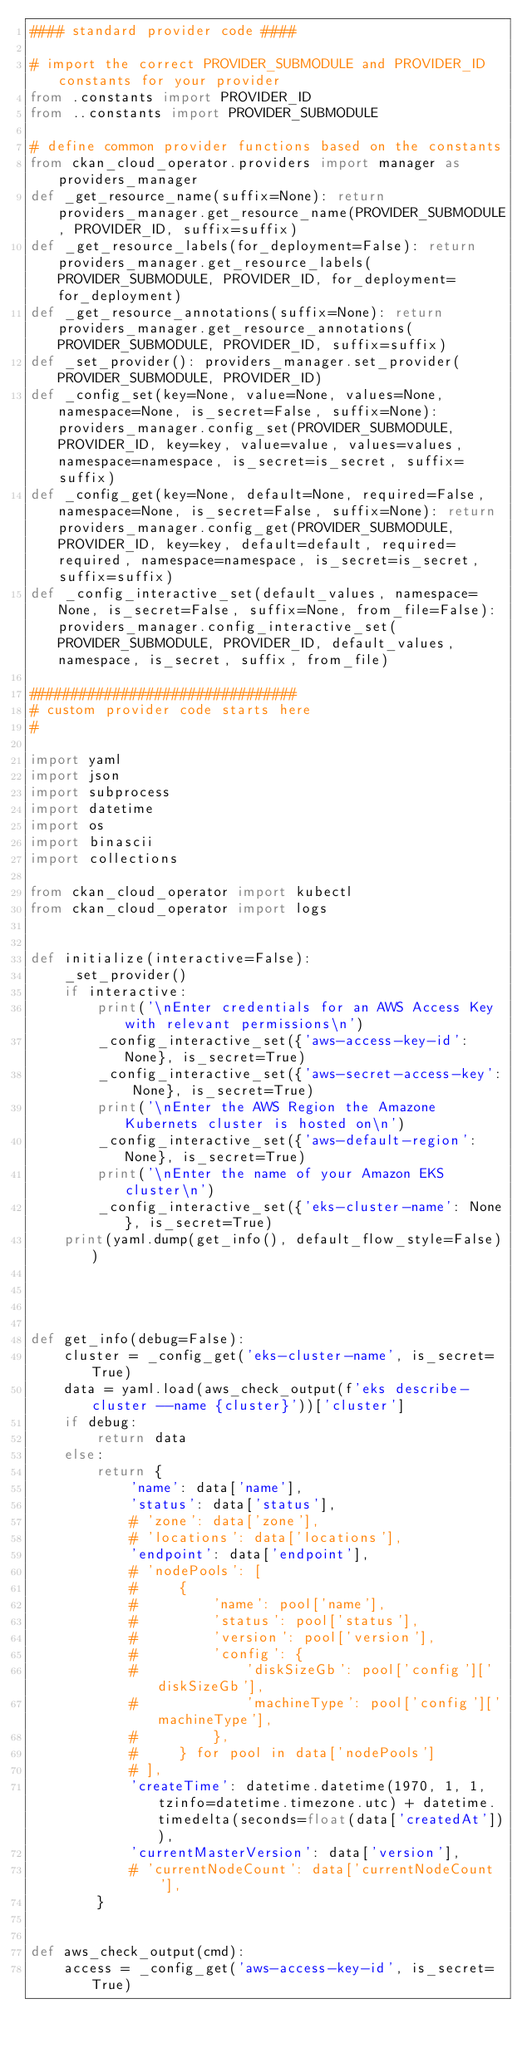Convert code to text. <code><loc_0><loc_0><loc_500><loc_500><_Python_>#### standard provider code ####

# import the correct PROVIDER_SUBMODULE and PROVIDER_ID constants for your provider
from .constants import PROVIDER_ID
from ..constants import PROVIDER_SUBMODULE

# define common provider functions based on the constants
from ckan_cloud_operator.providers import manager as providers_manager
def _get_resource_name(suffix=None): return providers_manager.get_resource_name(PROVIDER_SUBMODULE, PROVIDER_ID, suffix=suffix)
def _get_resource_labels(for_deployment=False): return providers_manager.get_resource_labels(PROVIDER_SUBMODULE, PROVIDER_ID, for_deployment=for_deployment)
def _get_resource_annotations(suffix=None): return providers_manager.get_resource_annotations(PROVIDER_SUBMODULE, PROVIDER_ID, suffix=suffix)
def _set_provider(): providers_manager.set_provider(PROVIDER_SUBMODULE, PROVIDER_ID)
def _config_set(key=None, value=None, values=None, namespace=None, is_secret=False, suffix=None): providers_manager.config_set(PROVIDER_SUBMODULE, PROVIDER_ID, key=key, value=value, values=values, namespace=namespace, is_secret=is_secret, suffix=suffix)
def _config_get(key=None, default=None, required=False, namespace=None, is_secret=False, suffix=None): return providers_manager.config_get(PROVIDER_SUBMODULE, PROVIDER_ID, key=key, default=default, required=required, namespace=namespace, is_secret=is_secret, suffix=suffix)
def _config_interactive_set(default_values, namespace=None, is_secret=False, suffix=None, from_file=False): providers_manager.config_interactive_set(PROVIDER_SUBMODULE, PROVIDER_ID, default_values, namespace, is_secret, suffix, from_file)

################################
# custom provider code starts here
#

import yaml
import json
import subprocess
import datetime
import os
import binascii
import collections

from ckan_cloud_operator import kubectl
from ckan_cloud_operator import logs


def initialize(interactive=False):
    _set_provider()
    if interactive:
        print('\nEnter credentials for an AWS Access Key with relevant permissions\n')
        _config_interactive_set({'aws-access-key-id': None}, is_secret=True)
        _config_interactive_set({'aws-secret-access-key': None}, is_secret=True)
        print('\nEnter the AWS Region the Amazone Kubernets cluster is hosted on\n')
        _config_interactive_set({'aws-default-region': None}, is_secret=True)
        print('\nEnter the name of your Amazon EKS cluster\n')
        _config_interactive_set({'eks-cluster-name': None}, is_secret=True)
    print(yaml.dump(get_info(), default_flow_style=False))




def get_info(debug=False):
    cluster = _config_get('eks-cluster-name', is_secret=True)
    data = yaml.load(aws_check_output(f'eks describe-cluster --name {cluster}'))['cluster']
    if debug:
        return data
    else:
        return {
            'name': data['name'],
            'status': data['status'],
            # 'zone': data['zone'],
            # 'locations': data['locations'],
            'endpoint': data['endpoint'],
            # 'nodePools': [
            #     {
            #         'name': pool['name'],
            #         'status': pool['status'],
            #         'version': pool['version'],
            #         'config': {
            #             'diskSizeGb': pool['config']['diskSizeGb'],
            #             'machineType': pool['config']['machineType'],
            #         },
            #     } for pool in data['nodePools']
            # ],
            'createTime': datetime.datetime(1970, 1, 1, tzinfo=datetime.timezone.utc) + datetime.timedelta(seconds=float(data['createdAt'])),
            'currentMasterVersion': data['version'],
            # 'currentNodeCount': data['currentNodeCount'],
        }


def aws_check_output(cmd):
    access = _config_get('aws-access-key-id', is_secret=True)</code> 